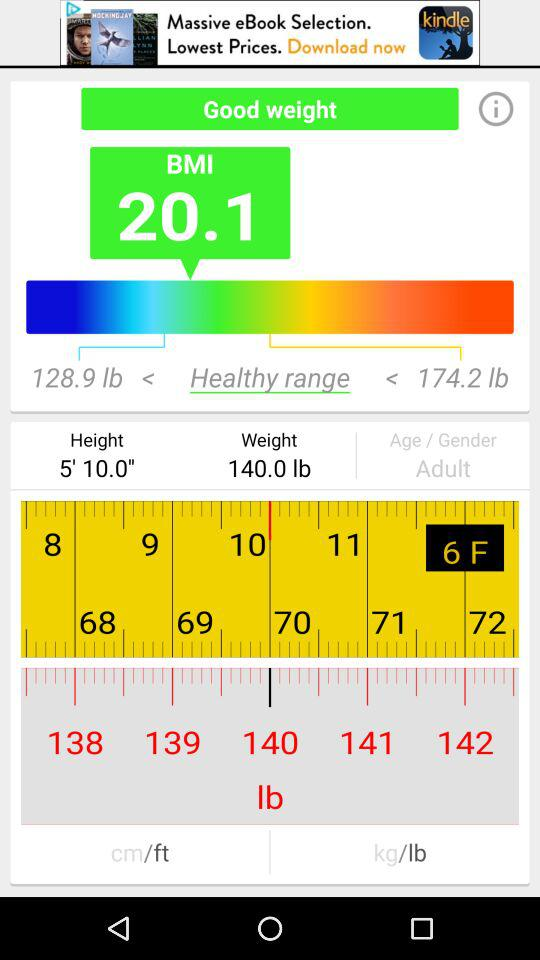How old is the user?
Answer the question using a single word or phrase. Adult 